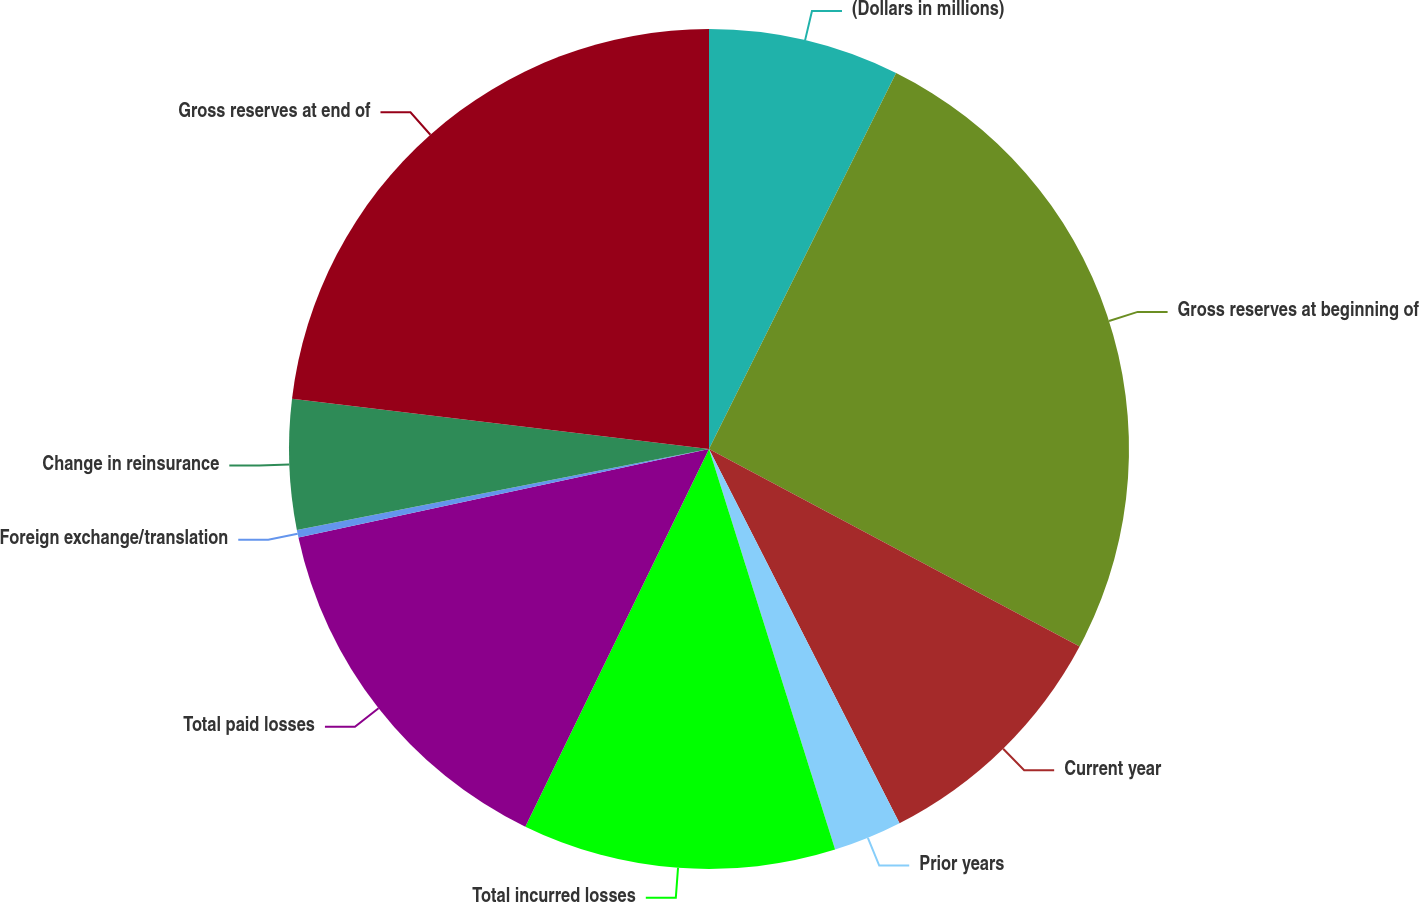Convert chart to OTSL. <chart><loc_0><loc_0><loc_500><loc_500><pie_chart><fcel>(Dollars in millions)<fcel>Gross reserves at beginning of<fcel>Current year<fcel>Prior years<fcel>Total incurred losses<fcel>Total paid losses<fcel>Foreign exchange/translation<fcel>Change in reinsurance<fcel>Gross reserves at end of<nl><fcel>7.35%<fcel>25.45%<fcel>9.71%<fcel>2.64%<fcel>12.06%<fcel>14.42%<fcel>0.29%<fcel>5.0%<fcel>23.09%<nl></chart> 